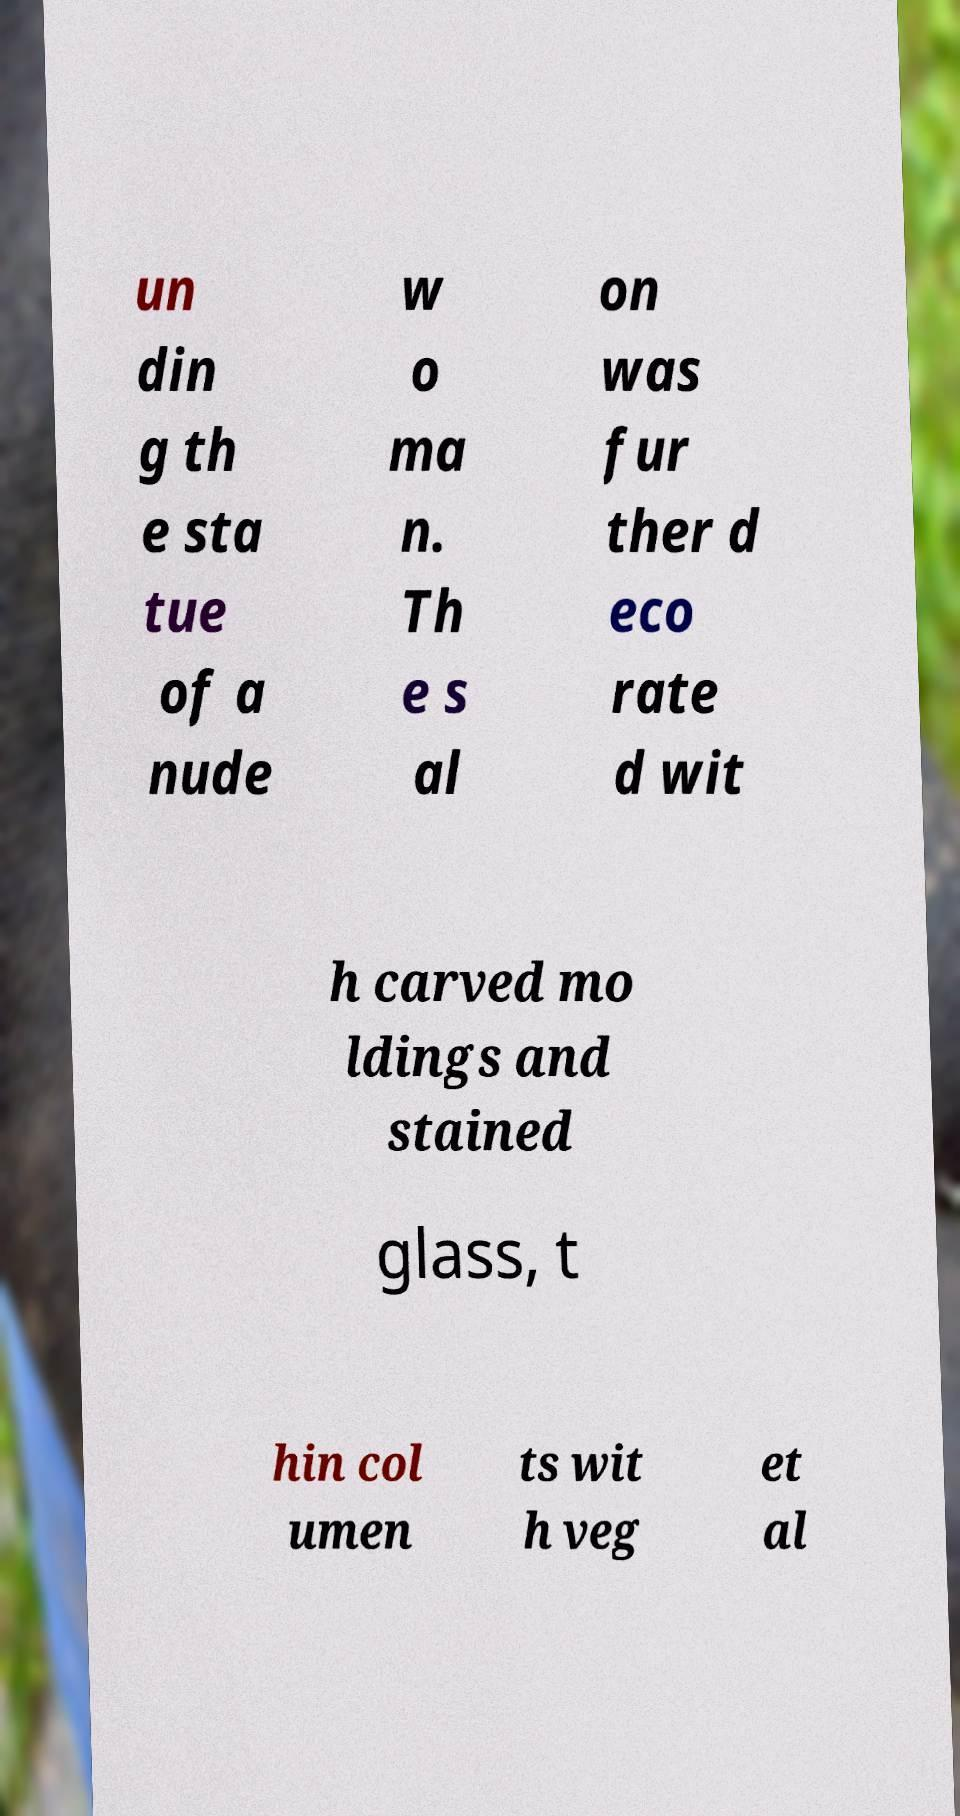Could you extract and type out the text from this image? un din g th e sta tue of a nude w o ma n. Th e s al on was fur ther d eco rate d wit h carved mo ldings and stained glass, t hin col umen ts wit h veg et al 